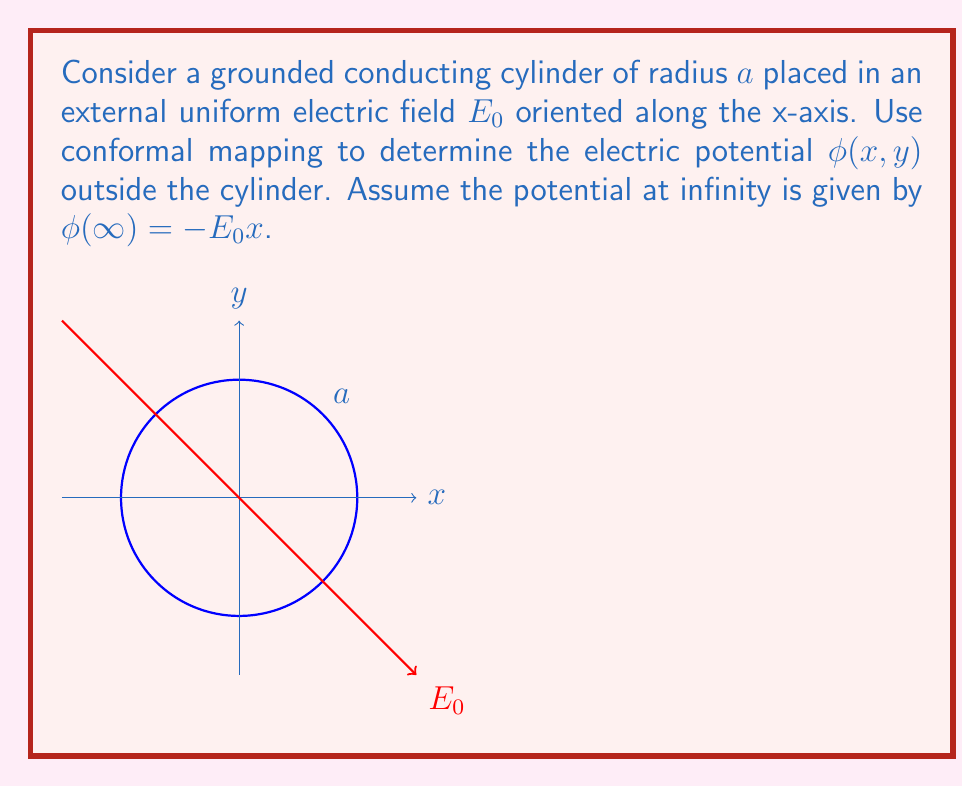Provide a solution to this math problem. To solve this problem, we'll use the following steps:

1) The conformal mapping $w = \frac{a^2}{z}$ transforms the region outside the cylinder to the inside of a circle of radius $a$ in the w-plane.

2) In the w-plane, the potential satisfies Laplace's equation $\nabla^2\phi = 0$. The general solution in polar coordinates $(r,\theta)$ is:

   $$\phi(r,\theta) = \sum_{n=0}^{\infty} (A_n r^n + B_n r^{-n}) (C_n \cos(n\theta) + D_n \sin(n\theta))$$

3) Given the symmetry of the problem and the boundary conditions, we can simplify this to:

   $$\phi(r,\theta) = A r \cos(\theta) + \frac{B}{r} \cos(\theta)$$

4) In the original z-plane, $z = x + iy = re^{i\theta}$, so $x = r\cos(\theta)$. The boundary condition at infinity becomes:

   $$\phi(\infty) = -E_0x = -E_0 r \cos(\theta)$$

   This gives us $A = -E_0$.

5) The boundary condition on the cylinder (grounded, $\phi = 0$ at $r = a$) gives:

   $$0 = -E_0 a \cos(\theta) + \frac{B}{a} \cos(\theta)$$

   This yields $B = E_0 a^2$.

6) Therefore, in the w-plane, the potential is:

   $$\phi(r,\theta) = -E_0 r \cos(\theta) + E_0 \frac{a^2}{r} \cos(\theta)$$

7) To transform back to the z-plane, we use $w = \frac{a^2}{z} = \frac{a^2}{x+iy}$. This gives:

   $$r = \frac{a^2}{\sqrt{x^2+y^2}}, \quad \cos(\theta) = \frac{x}{\sqrt{x^2+y^2}}$$

8) Substituting these into our potential function:

   $$\phi(x,y) = -E_0 \frac{a^2}{\sqrt{x^2+y^2}} \frac{x}{\sqrt{x^2+y^2}} + E_0 \frac{\sqrt{x^2+y^2}}{a^2} \frac{x}{\sqrt{x^2+y^2}}$$

9) Simplifying:

   $$\phi(x,y) = -E_0 x \left(1 - \frac{a^2}{x^2+y^2}\right)$$

This is the final expression for the electric potential outside the cylinder.
Answer: $$\phi(x,y) = -E_0 x \left(1 - \frac{a^2}{x^2+y^2}\right)$$ 